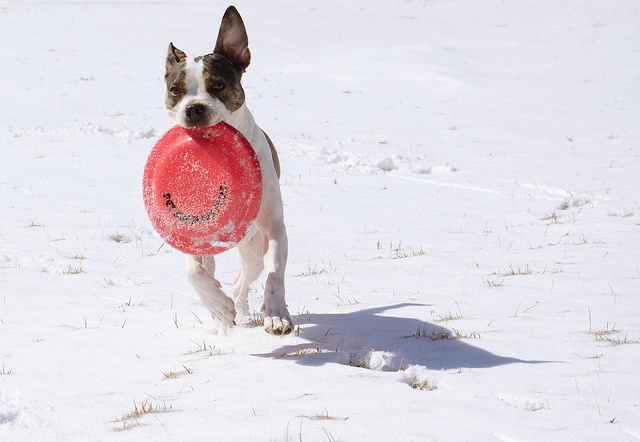Describe the objects in this image and their specific colors. I can see dog in lavender, salmon, darkgray, lightpink, and lightgray tones and frisbee in lavender, salmon, lightpink, and brown tones in this image. 